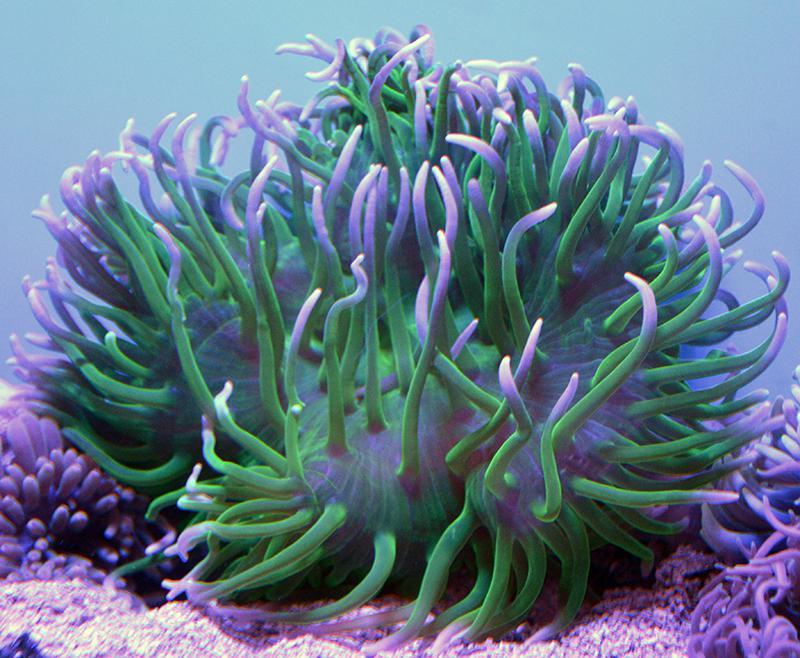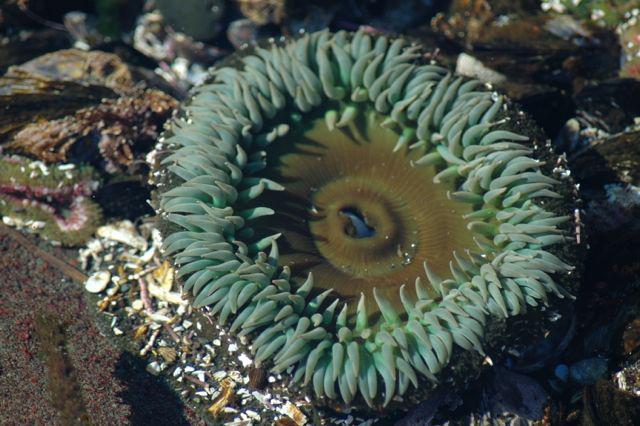The first image is the image on the left, the second image is the image on the right. Given the left and right images, does the statement "One image shows a flower-like anemone with mint green tendrils and a darker yellowish center with a visible slit in it." hold true? Answer yes or no. Yes. The first image is the image on the left, the second image is the image on the right. Examine the images to the left and right. Is the description "The left image contains a green and purple anemone, while the right has a green one." accurate? Answer yes or no. Yes. 